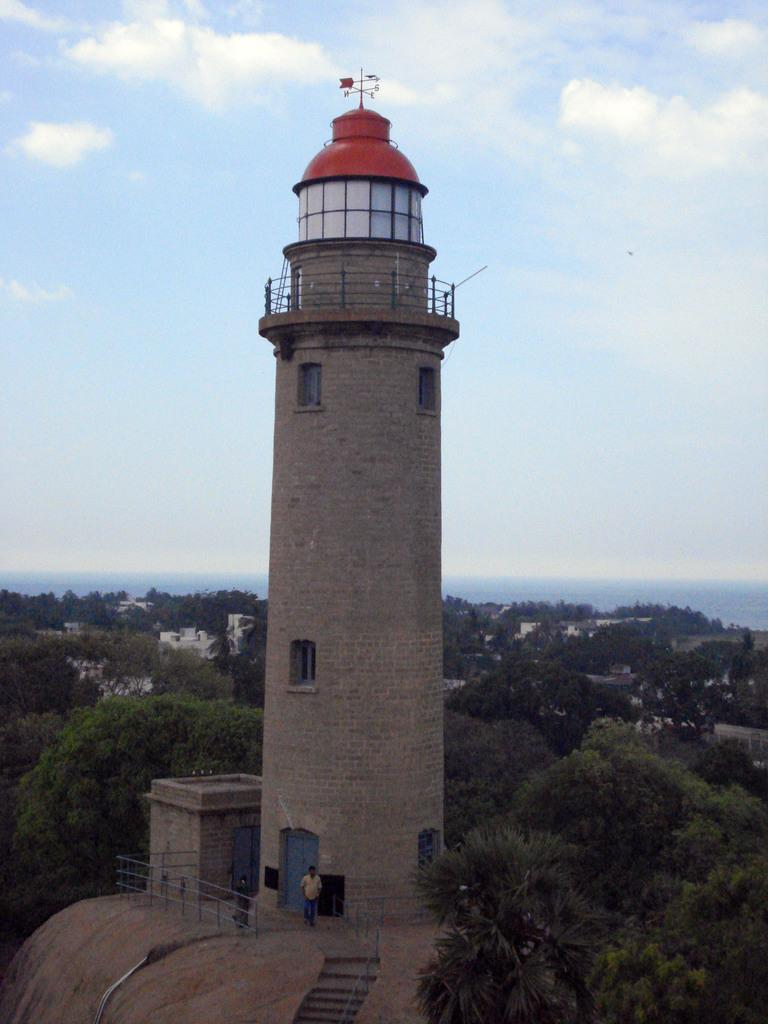What is the main structure in the image? There is a tower in the image. What feature can be seen on the tower? There is railing in the image. Are there any architectural elements that allow access to the tower? Yes, there are steps in the image. What type of vegetation is present in the image? There are trees in the image. Is there any additional structure in the image? Yes, there is a shed in the image. What type of buildings are visible in the image? There are buildings in the image What type of fruit is being harvested by the people in the image? There are no people harvesting fruit in the image; there are only two people present. What type of destruction is visible in the image? There is no destruction visible in the image; it appears to be a peaceful scene with a tower, buildings, trees, and people. 